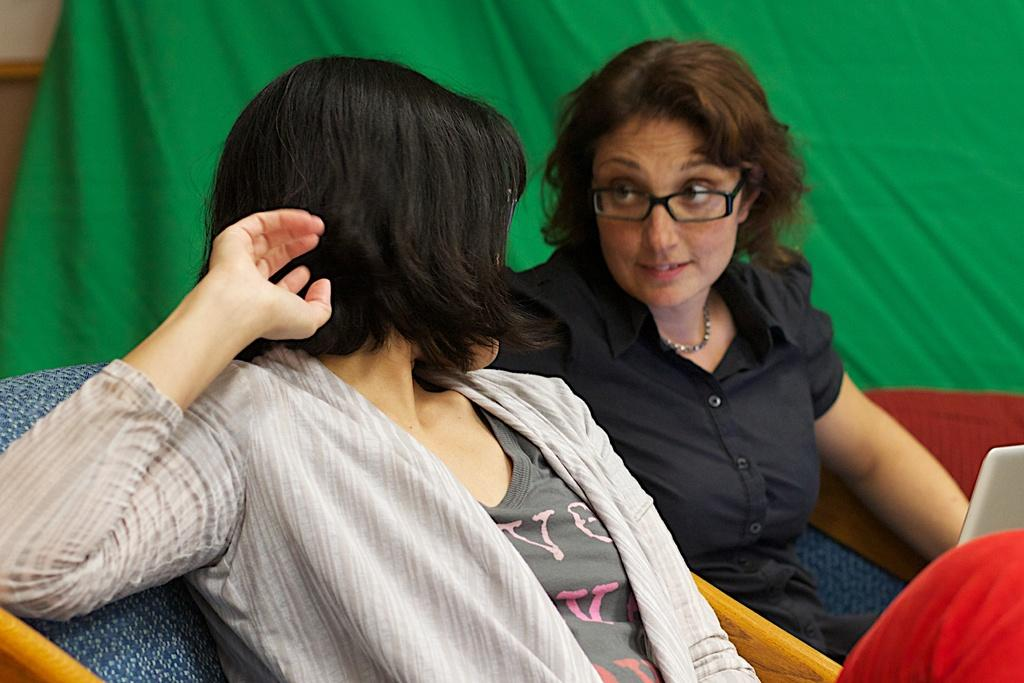What are the women in the image doing? The women are sitting in the chairs in the image. What can be seen in the background of the image? There is a wall and a green color cloth in the background of the image. What type of needle is being used by the women in the image? There is no needle present in the image; the women are sitting in chairs. 